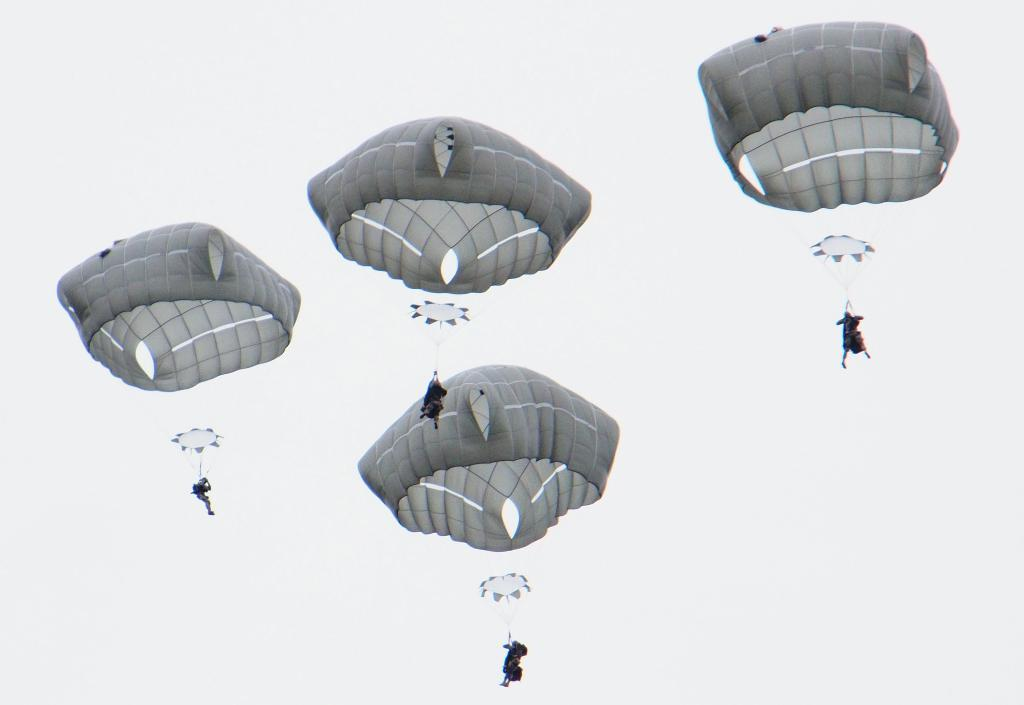How many people are in the image? There are four persons in the image. What are the persons holding in the image? The persons are holding parachutes. What is the color scheme of the image? The image is in black and white. What type of laborer can be seen working near the mailbox in the image? There is no laborer or mailbox present in the image; it features four persons holding parachutes. 